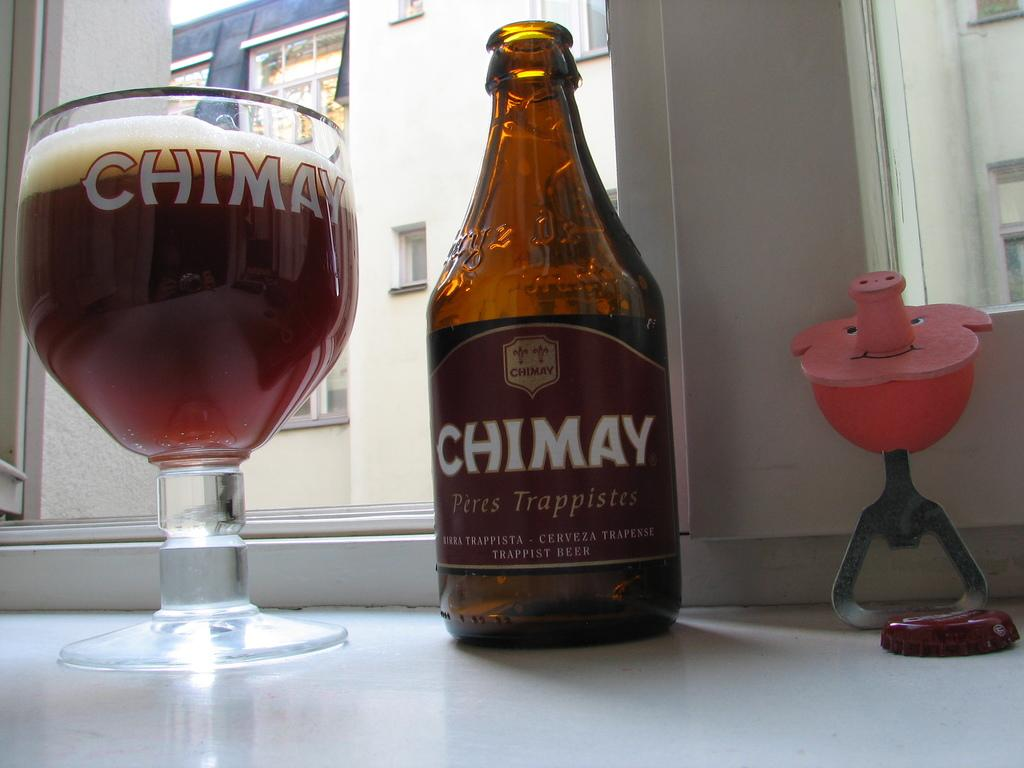What type of structure is visible in the image? There is a building in the image. Can you describe any specific features of the building? There is a window in the image, which is a feature of the building. What material is used for the window? There is glass in the image, which is used for the window. What object can be seen on a table in the image? There is a bottle on a table in the image. How many cows are visible in the image? There are no cows present in the image. What emotion is being expressed by the building in the image? Buildings do not express emotions, so this question cannot be answered. 